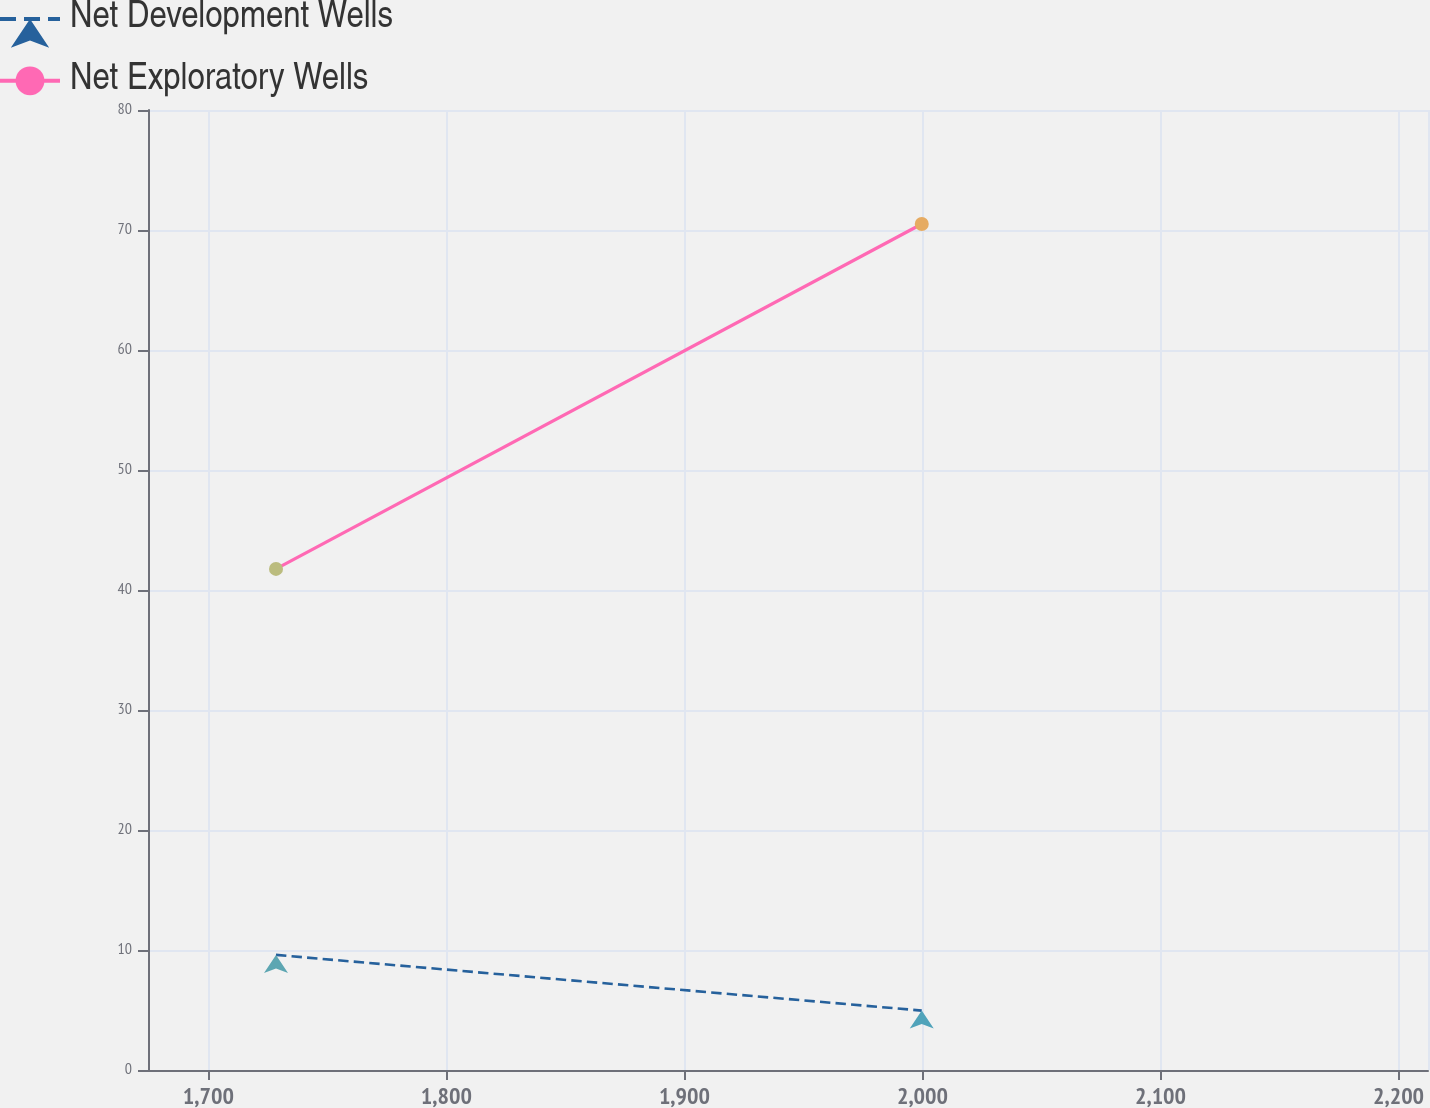Convert chart to OTSL. <chart><loc_0><loc_0><loc_500><loc_500><line_chart><ecel><fcel>Net Development Wells<fcel>Net Exploratory Wells<nl><fcel>1728.43<fcel>9.59<fcel>41.76<nl><fcel>1999.7<fcel>4.95<fcel>70.5<nl><fcel>2266.14<fcel>15.52<fcel>111.39<nl></chart> 